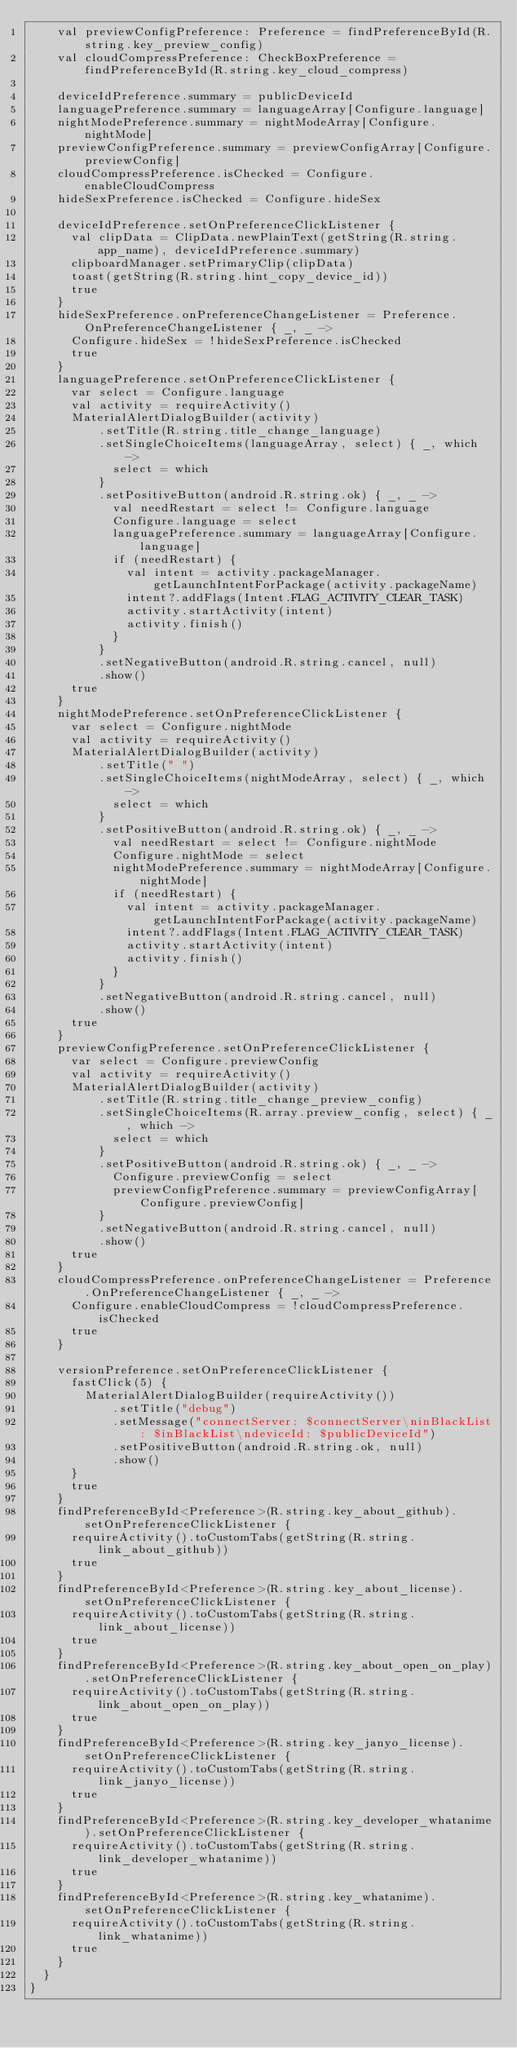<code> <loc_0><loc_0><loc_500><loc_500><_Kotlin_>		val previewConfigPreference: Preference = findPreferenceById(R.string.key_preview_config)
		val cloudCompressPreference: CheckBoxPreference = findPreferenceById(R.string.key_cloud_compress)

		deviceIdPreference.summary = publicDeviceId
		languagePreference.summary = languageArray[Configure.language]
		nightModePreference.summary = nightModeArray[Configure.nightMode]
		previewConfigPreference.summary = previewConfigArray[Configure.previewConfig]
		cloudCompressPreference.isChecked = Configure.enableCloudCompress
		hideSexPreference.isChecked = Configure.hideSex

		deviceIdPreference.setOnPreferenceClickListener {
			val clipData = ClipData.newPlainText(getString(R.string.app_name), deviceIdPreference.summary)
			clipboardManager.setPrimaryClip(clipData)
			toast(getString(R.string.hint_copy_device_id))
			true
		}
		hideSexPreference.onPreferenceChangeListener = Preference.OnPreferenceChangeListener { _, _ ->
			Configure.hideSex = !hideSexPreference.isChecked
			true
		}
		languagePreference.setOnPreferenceClickListener {
			var select = Configure.language
			val activity = requireActivity()
			MaterialAlertDialogBuilder(activity)
					.setTitle(R.string.title_change_language)
					.setSingleChoiceItems(languageArray, select) { _, which ->
						select = which
					}
					.setPositiveButton(android.R.string.ok) { _, _ ->
						val needRestart = select != Configure.language
						Configure.language = select
						languagePreference.summary = languageArray[Configure.language]
						if (needRestart) {
							val intent = activity.packageManager.getLaunchIntentForPackage(activity.packageName)
							intent?.addFlags(Intent.FLAG_ACTIVITY_CLEAR_TASK)
							activity.startActivity(intent)
							activity.finish()
						}
					}
					.setNegativeButton(android.R.string.cancel, null)
					.show()
			true
		}
		nightModePreference.setOnPreferenceClickListener {
			var select = Configure.nightMode
			val activity = requireActivity()
			MaterialAlertDialogBuilder(activity)
					.setTitle(" ")
					.setSingleChoiceItems(nightModeArray, select) { _, which ->
						select = which
					}
					.setPositiveButton(android.R.string.ok) { _, _ ->
						val needRestart = select != Configure.nightMode
						Configure.nightMode = select
						nightModePreference.summary = nightModeArray[Configure.nightMode]
						if (needRestart) {
							val intent = activity.packageManager.getLaunchIntentForPackage(activity.packageName)
							intent?.addFlags(Intent.FLAG_ACTIVITY_CLEAR_TASK)
							activity.startActivity(intent)
							activity.finish()
						}
					}
					.setNegativeButton(android.R.string.cancel, null)
					.show()
			true
		}
		previewConfigPreference.setOnPreferenceClickListener {
			var select = Configure.previewConfig
			val activity = requireActivity()
			MaterialAlertDialogBuilder(activity)
					.setTitle(R.string.title_change_preview_config)
					.setSingleChoiceItems(R.array.preview_config, select) { _, which ->
						select = which
					}
					.setPositiveButton(android.R.string.ok) { _, _ ->
						Configure.previewConfig = select
						previewConfigPreference.summary = previewConfigArray[Configure.previewConfig]
					}
					.setNegativeButton(android.R.string.cancel, null)
					.show()
			true
		}
		cloudCompressPreference.onPreferenceChangeListener = Preference.OnPreferenceChangeListener { _, _ ->
			Configure.enableCloudCompress = !cloudCompressPreference.isChecked
			true
		}

		versionPreference.setOnPreferenceClickListener {
			fastClick(5) {
				MaterialAlertDialogBuilder(requireActivity())
						.setTitle("debug")
						.setMessage("connectServer: $connectServer\ninBlackList: $inBlackList\ndeviceId: $publicDeviceId")
						.setPositiveButton(android.R.string.ok, null)
						.show()
			}
			true
		}
		findPreferenceById<Preference>(R.string.key_about_github).setOnPreferenceClickListener {
			requireActivity().toCustomTabs(getString(R.string.link_about_github))
			true
		}
		findPreferenceById<Preference>(R.string.key_about_license).setOnPreferenceClickListener {
			requireActivity().toCustomTabs(getString(R.string.link_about_license))
			true
		}
		findPreferenceById<Preference>(R.string.key_about_open_on_play).setOnPreferenceClickListener {
			requireActivity().toCustomTabs(getString(R.string.link_about_open_on_play))
			true
		}
		findPreferenceById<Preference>(R.string.key_janyo_license).setOnPreferenceClickListener {
			requireActivity().toCustomTabs(getString(R.string.link_janyo_license))
			true
		}
		findPreferenceById<Preference>(R.string.key_developer_whatanime).setOnPreferenceClickListener {
			requireActivity().toCustomTabs(getString(R.string.link_developer_whatanime))
			true
		}
		findPreferenceById<Preference>(R.string.key_whatanime).setOnPreferenceClickListener {
			requireActivity().toCustomTabs(getString(R.string.link_whatanime))
			true
		}
	}
}</code> 